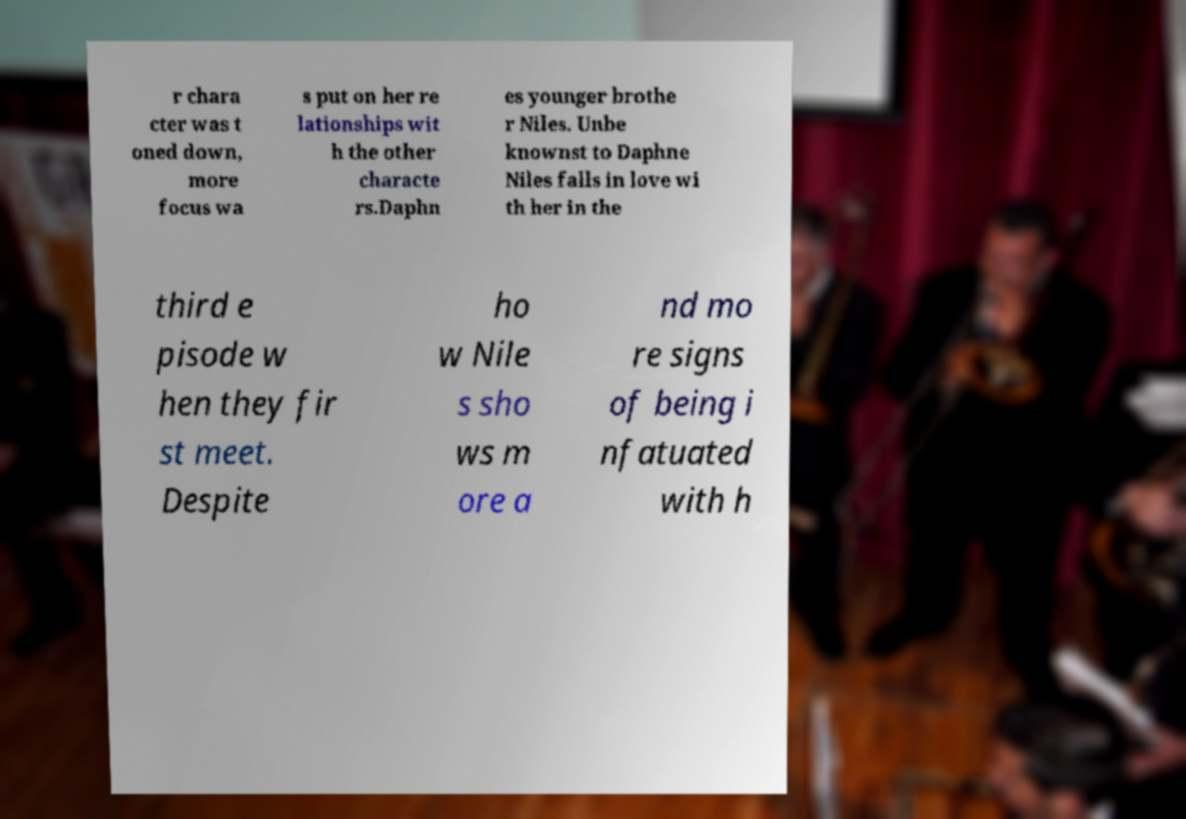I need the written content from this picture converted into text. Can you do that? r chara cter was t oned down, more focus wa s put on her re lationships wit h the other characte rs.Daphn es younger brothe r Niles. Unbe knownst to Daphne Niles falls in love wi th her in the third e pisode w hen they fir st meet. Despite ho w Nile s sho ws m ore a nd mo re signs of being i nfatuated with h 